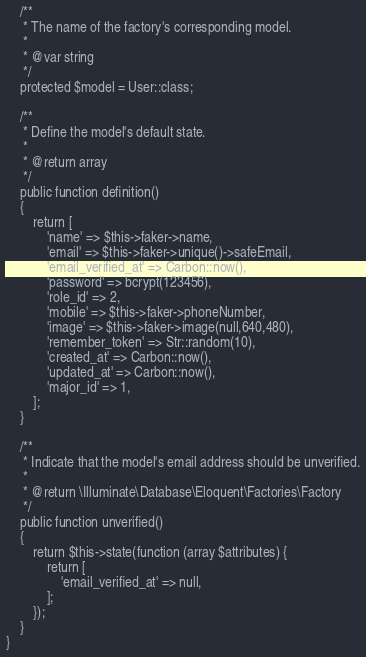<code> <loc_0><loc_0><loc_500><loc_500><_PHP_>    /**
     * The name of the factory's corresponding model.
     *
     * @var string
     */
    protected $model = User::class;

    /**
     * Define the model's default state.
     *
     * @return array
     */
    public function definition()
    {
        return [
            'name' => $this->faker->name,
            'email' => $this->faker->unique()->safeEmail,
            'email_verified_at' => Carbon::now(),
            'password' => bcrypt(123456),
            'role_id' => 2,
            'mobile' => $this->faker->phoneNumber,
            'image' => $this->faker->image(null,640,480),
            'remember_token' => Str::random(10),
            'created_at' => Carbon::now(),
            'updated_at' => Carbon::now(),
            'major_id' => 1,
        ];
    }

    /**
     * Indicate that the model's email address should be unverified.
     *
     * @return \Illuminate\Database\Eloquent\Factories\Factory
     */
    public function unverified()
    {
        return $this->state(function (array $attributes) {
            return [
                'email_verified_at' => null,
            ];
        });
    }
}
</code> 